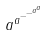Convert formula to latex. <formula><loc_0><loc_0><loc_500><loc_500>a ^ { a ^ { - ^ { - ^ { a ^ { a } } } } }</formula> 